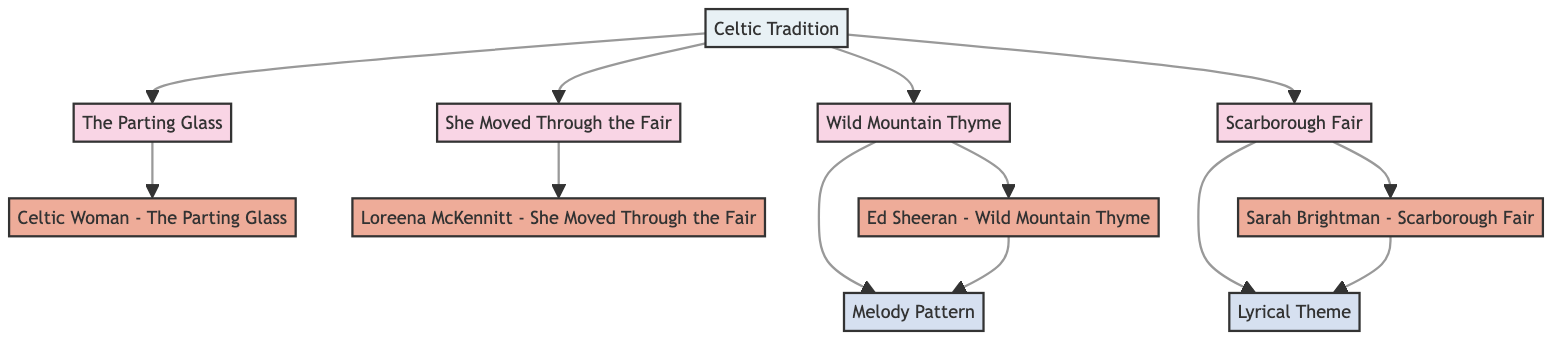What are the types of songs represented in the diagram? The diagram includes two types of songs: "TraditionalSong" and "ModernAdaptation." This is evident from the class definitions where each song is labeled with its type.
Answer: TraditionalSong, ModernAdaptation How many traditional songs are represented? The diagram lists four traditional songs: "The Parting Glass", "She Moved Through the Fair", "Wild Mountain Thyme", and "Scarborough Fair." They are directly counted in the diagram for clarity.
Answer: 4 Which modern adaptation is associated with "Wild Mountain Thyme"? The node for "Wild Mountain Thyme" has an outgoing edge connected to "Ed Sheeran - Wild Mountain Thyme," indicating this specific modern adaptation.
Answer: Ed Sheeran - Wild Mountain Thyme What is the dependency of the "Melody Pattern"? The "Melody Pattern" has dependencies on "Wild Mountain Thyme" and "Ed Sheeran - Wild Mountain Thyme," which can be traced via the directed edges leading towards the "Melody Pattern" node in the diagram.
Answer: Wild Mountain Thyme, Ed Sheeran - Wild Mountain Thyme How many modern adaptations are connected to the traditional songs? There are four modern adaptations shown in the diagram: "Celtic Woman - The Parting Glass", "Loreena McKennitt - She Moved Through the Fair," "Ed Sheeran - Wild Mountain Thyme," and "Sarah Brightman - Scarborough Fair." Counting these gives a total of four.
Answer: 4 What is the significance of the "Celtic Tradition" in this diagram? The "Celtic Tradition" node depends on all four traditional songs, representing the cultural background that links the traditional songs to their modern adaptations. This dependency shows its foundational significance in the diagram’s context.
Answer: Cultural significance Which song adaptation did "Scarborough Fair" influence? The traditional song "Scarborough Fair" has a direct dependency that leads to "Sarah Brightman - Scarborough Fair," indicating that this is the specific modern adaptation influenced by it.
Answer: Sarah Brightman - Scarborough Fair What does the "Lyrical Theme" depend on? The "Lyrical Theme" has dependencies on the traditional songs "Scarborough Fair" and the modern adaptation "Sarah Brightman - Scarborough Fair," visible through the arrows leading into its node.
Answer: Scarborough Fair, Sarah Brightman - Scarborough Fair 